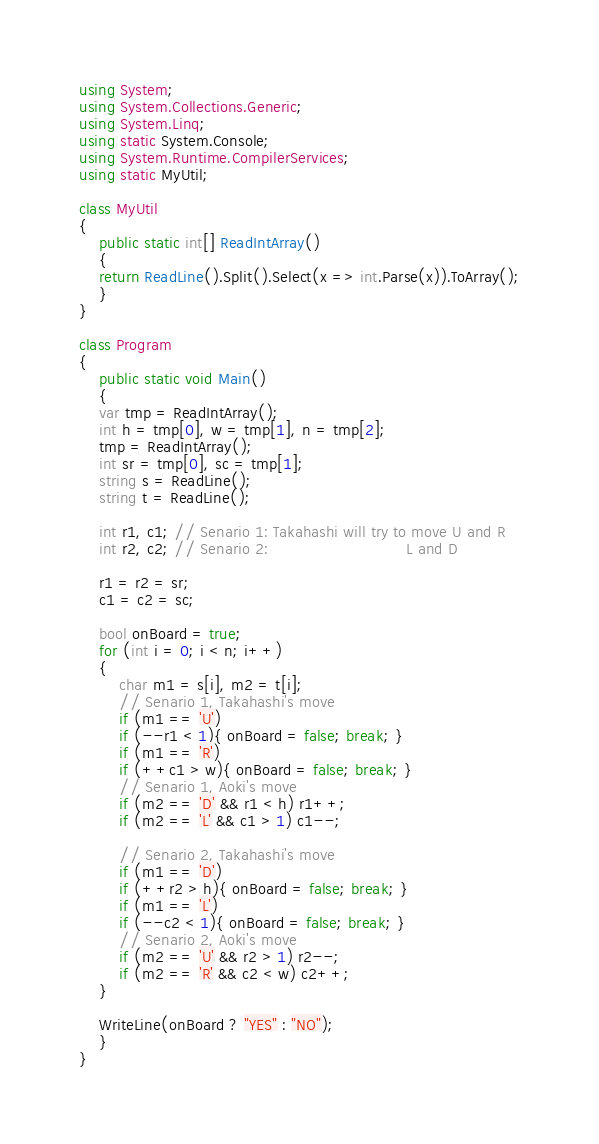Convert code to text. <code><loc_0><loc_0><loc_500><loc_500><_C#_>using System;
using System.Collections.Generic;
using System.Linq;
using static System.Console;
using System.Runtime.CompilerServices;
using static MyUtil;

class MyUtil
{
    public static int[] ReadIntArray()
    {
	return ReadLine().Split().Select(x => int.Parse(x)).ToArray();
    }
}

class Program
{
    public static void Main()
    {
	var tmp = ReadIntArray();
	int h = tmp[0], w = tmp[1], n = tmp[2];
	tmp = ReadIntArray();
	int sr = tmp[0], sc = tmp[1];
	string s = ReadLine();
	string t = ReadLine();

	int r1, c1; // Senario 1: Takahashi will try to move U and R
	int r2, c2; // Senario 2:                            L and D

	r1 = r2 = sr;
	c1 = c2 = sc;

	bool onBoard = true;
	for (int i = 0; i < n; i++)
	{
	    char m1 = s[i], m2 = t[i];
	    // Senario 1, Takahashi's move
	    if (m1 == 'U')
		if (--r1 < 1){ onBoard = false; break; }
	    if (m1 == 'R')
		if (++c1 > w){ onBoard = false; break; }
	    // Senario 1, Aoki's move
	    if (m2 == 'D' && r1 < h) r1++;
	    if (m2 == 'L' && c1 > 1) c1--;

	    // Senario 2, Takahashi's move
	    if (m1 == 'D')
		if (++r2 > h){ onBoard = false; break; }
	    if (m1 == 'L')
		if (--c2 < 1){ onBoard = false; break; }
	    // Senario 2, Aoki's move
	    if (m2 == 'U' && r2 > 1) r2--;
	    if (m2 == 'R' && c2 < w) c2++;
	}

	WriteLine(onBoard ? "YES" : "NO");
    }
}
</code> 